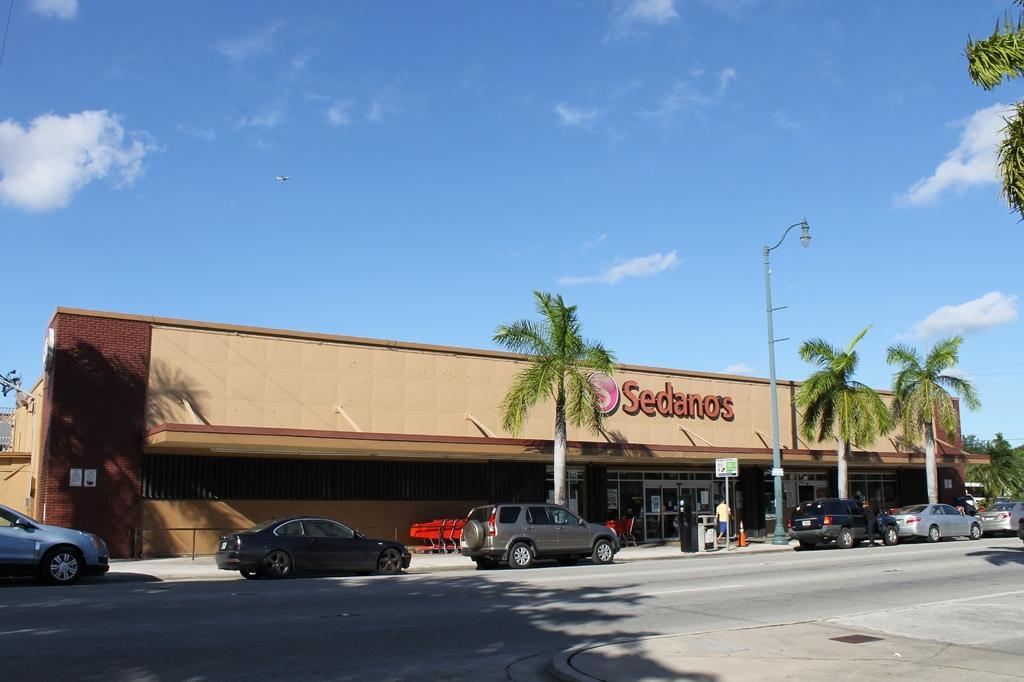Could you give a brief overview of what you see in this image? There are cars on the road. Here we can see a building, poles, trees, boards, and posters. In the background there is sky with clouds. 